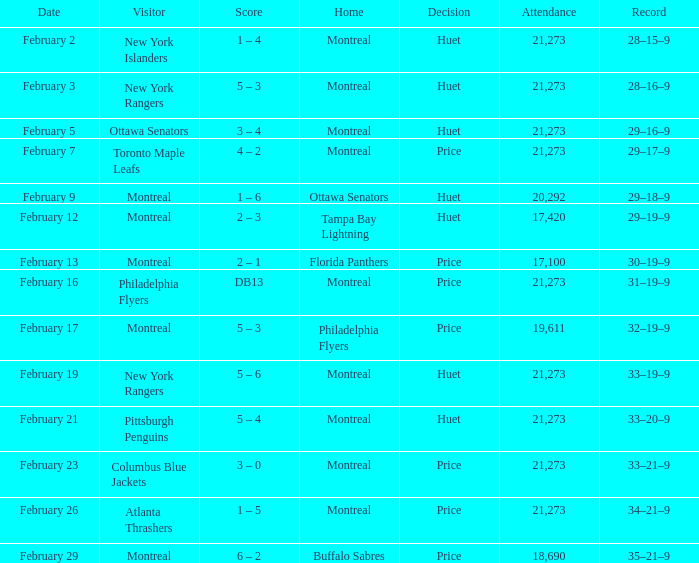Who was the visiting team at the game when the Canadiens had a record of 30–19–9? Montreal. 